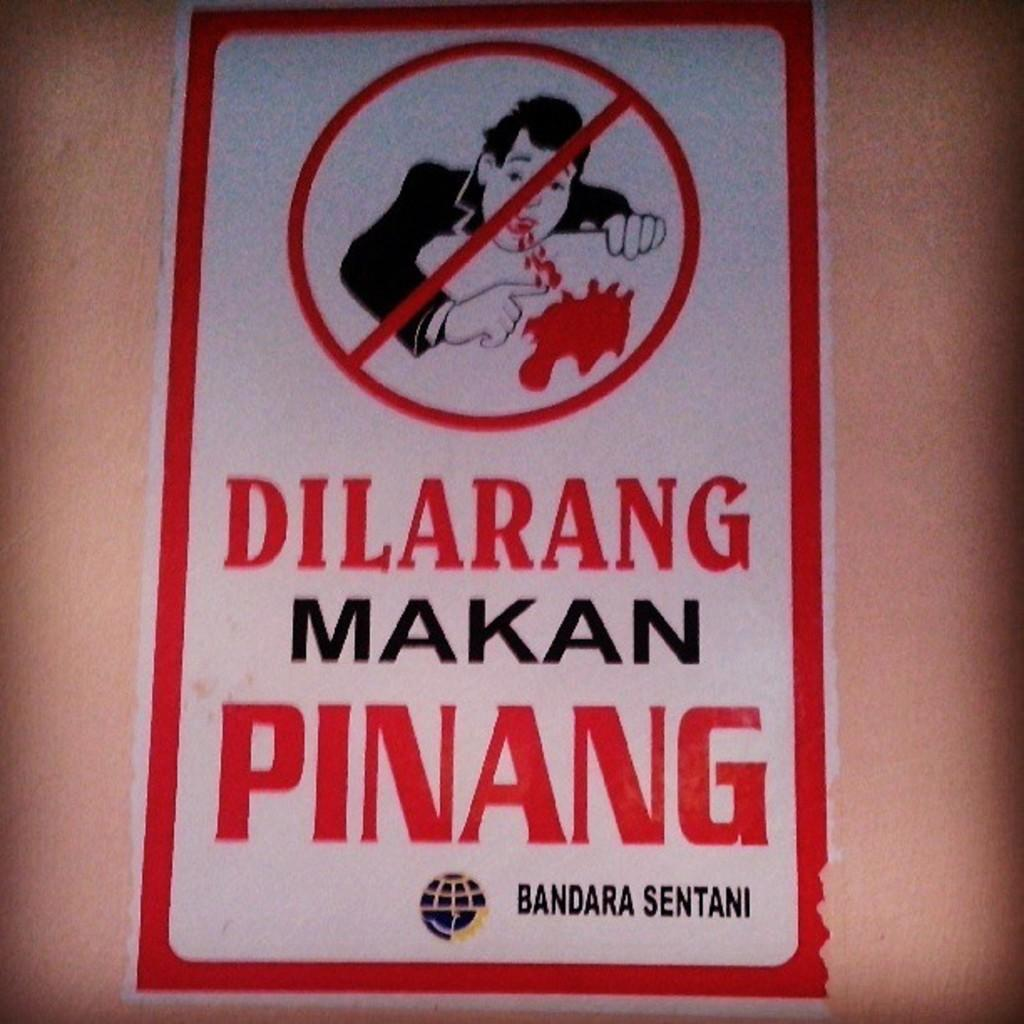<image>
Provide a brief description of the given image. A red and white sign with the words DILARANG MAKAN PINANG on it 